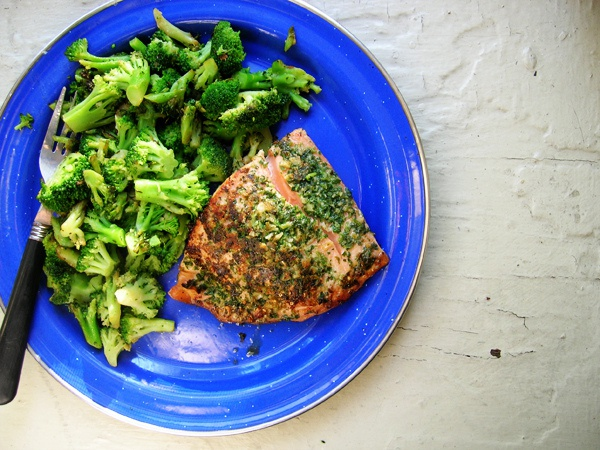Describe the objects in this image and their specific colors. I can see broccoli in darkgray, black, darkgreen, and green tones and fork in darkgray, black, darkblue, and darkgreen tones in this image. 